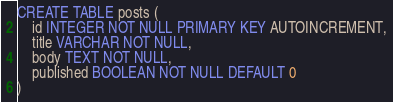<code> <loc_0><loc_0><loc_500><loc_500><_SQL_>CREATE TABLE posts (
    id INTEGER NOT NULL PRIMARY KEY AUTOINCREMENT,
    title VARCHAR NOT NULL,
    body TEXT NOT NULL,
    published BOOLEAN NOT NULL DEFAULT 0
)</code> 